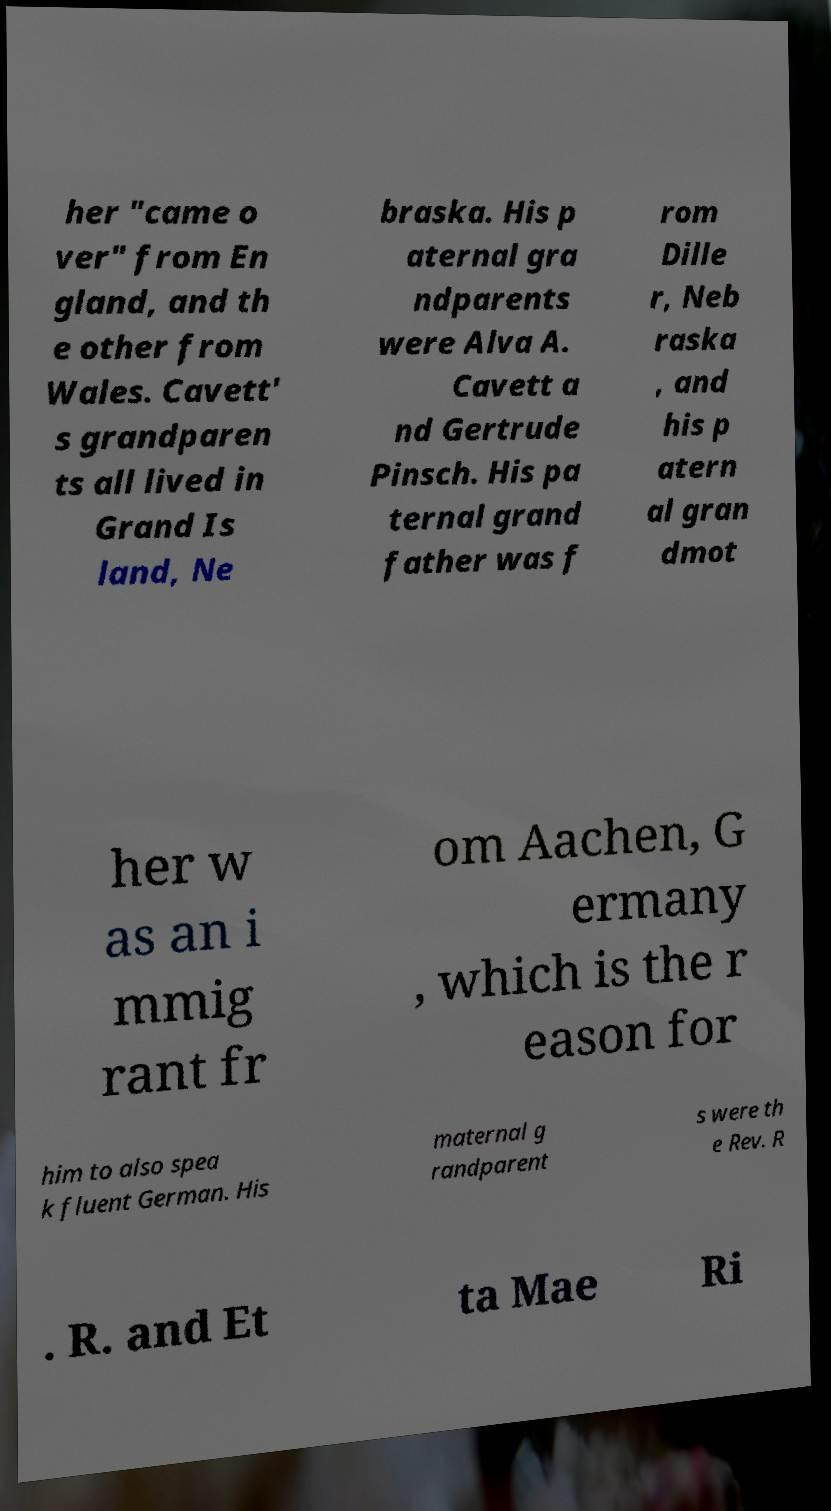Could you extract and type out the text from this image? her "came o ver" from En gland, and th e other from Wales. Cavett' s grandparen ts all lived in Grand Is land, Ne braska. His p aternal gra ndparents were Alva A. Cavett a nd Gertrude Pinsch. His pa ternal grand father was f rom Dille r, Neb raska , and his p atern al gran dmot her w as an i mmig rant fr om Aachen, G ermany , which is the r eason for him to also spea k fluent German. His maternal g randparent s were th e Rev. R . R. and Et ta Mae Ri 